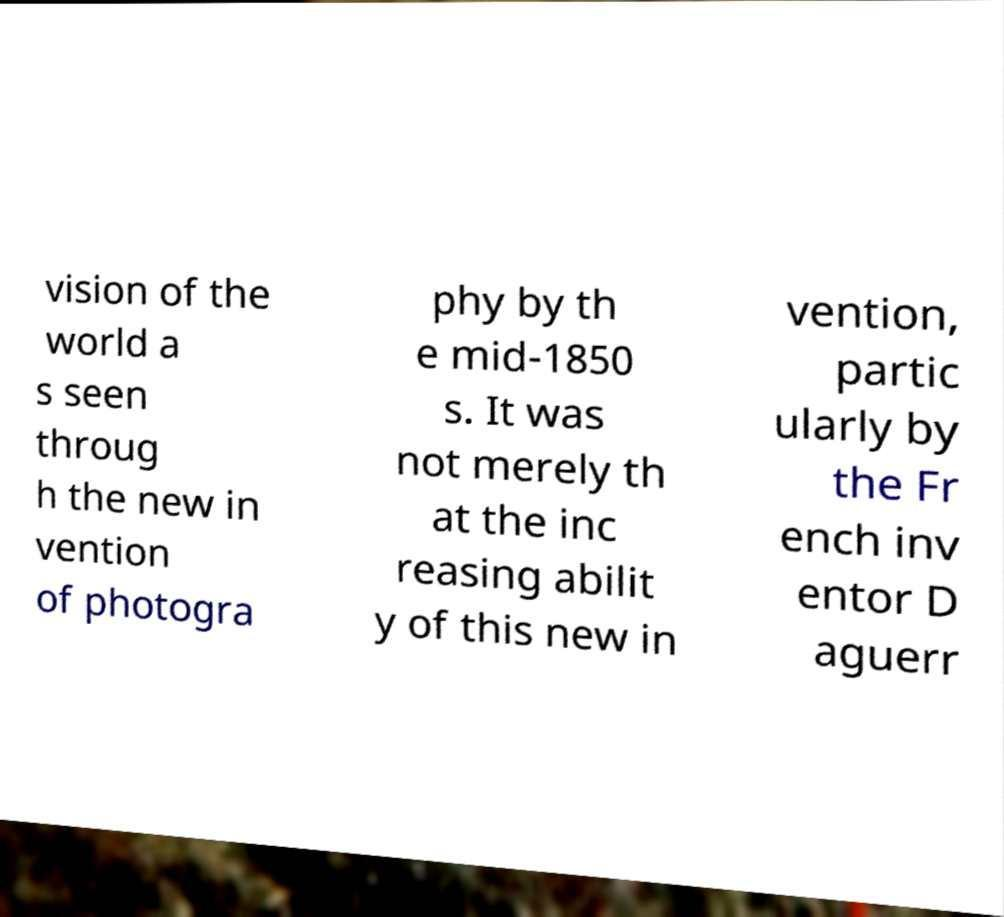Can you read and provide the text displayed in the image?This photo seems to have some interesting text. Can you extract and type it out for me? vision of the world a s seen throug h the new in vention of photogra phy by th e mid-1850 s. It was not merely th at the inc reasing abilit y of this new in vention, partic ularly by the Fr ench inv entor D aguerr 